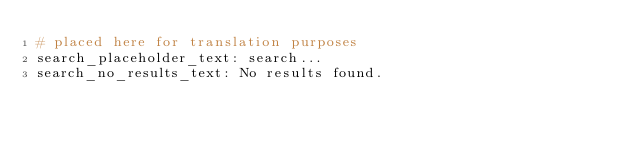<code> <loc_0><loc_0><loc_500><loc_500><_YAML_># placed here for translation purposes
search_placeholder_text: search...
search_no_results_text: No results found.
</code> 